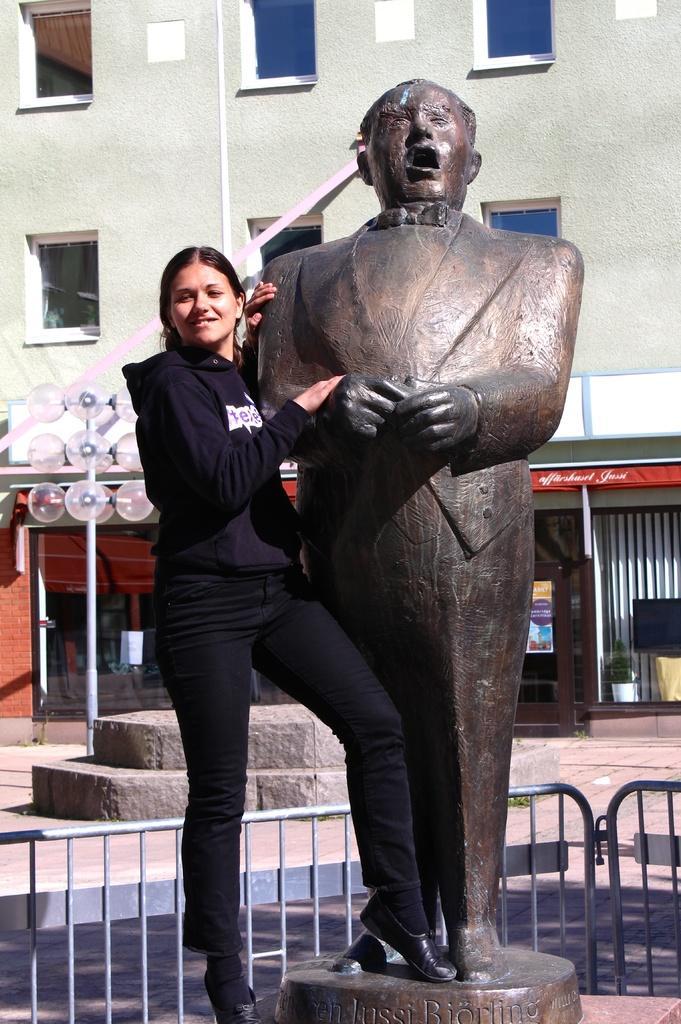Describe this image in one or two sentences. This picture is clicked outside. On the left we can see a woman standing. On the right there is a sculpture of a person. In the background we can see the guard rail and we can see the building, windows of the building and we can see the lights attached to the pole and some other objects. 